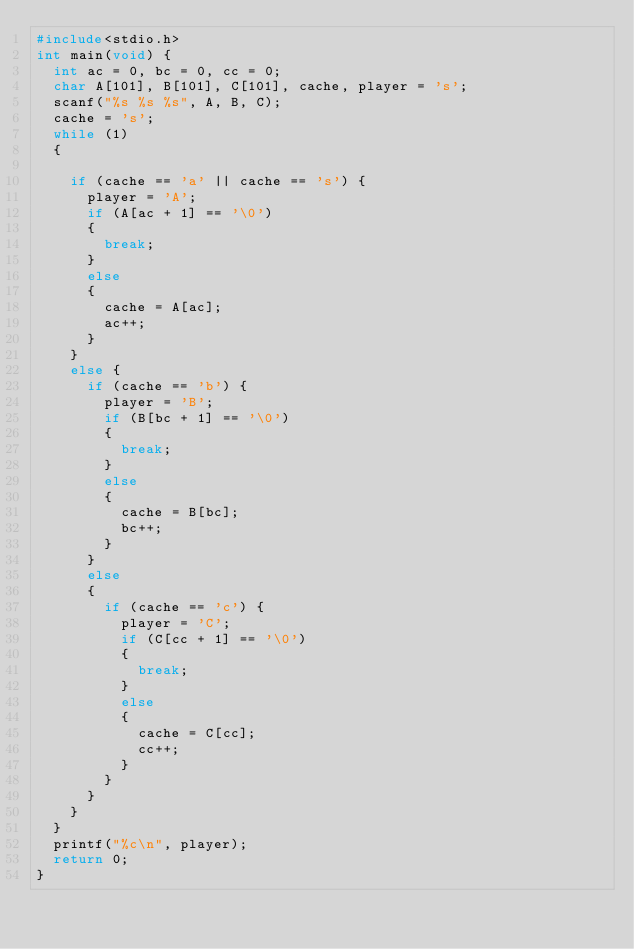Convert code to text. <code><loc_0><loc_0><loc_500><loc_500><_C++_>#include<stdio.h>
int main(void) {
	int ac = 0, bc = 0, cc = 0;
	char A[101], B[101], C[101], cache, player = 's';
	scanf("%s %s %s", A, B, C);
	cache = 's';
	while (1)
	{

		if (cache == 'a' || cache == 's') {
			player = 'A';
			if (A[ac + 1] == '\0')
			{
				break;
			}
			else
			{
				cache = A[ac];
				ac++;
			}
		}
		else {
			if (cache == 'b') {
				player = 'B';
				if (B[bc + 1] == '\0')
				{
					break;
				}
				else
				{
					cache = B[bc];
					bc++;
				}
			}
			else
			{
				if (cache == 'c') {
					player = 'C';
					if (C[cc + 1] == '\0')
					{
						break;
					}
					else
					{
						cache = C[cc];
						cc++;
					}
				}
			}
		}
	}
	printf("%c\n", player);
	return 0;
}</code> 